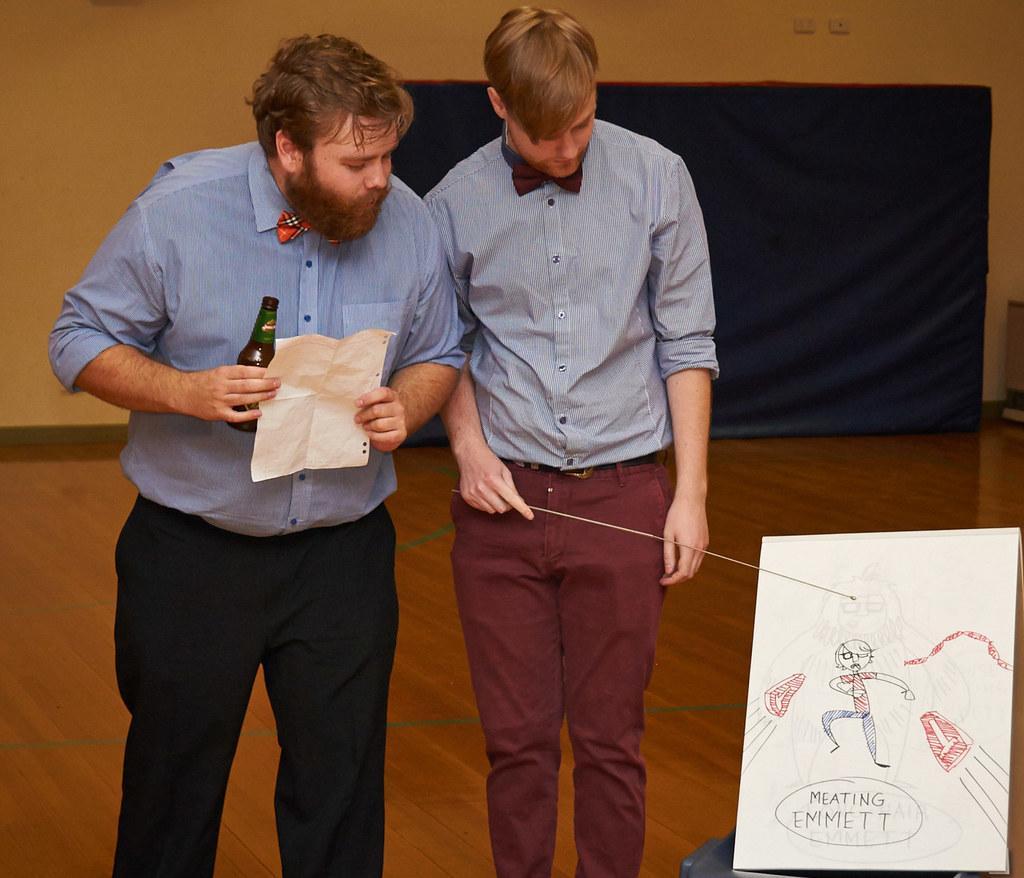Could you give a brief overview of what you see in this image? In the center of the image there are two persons standing. In the background of the image there is a wall. At the bottom of the image there is floor. 